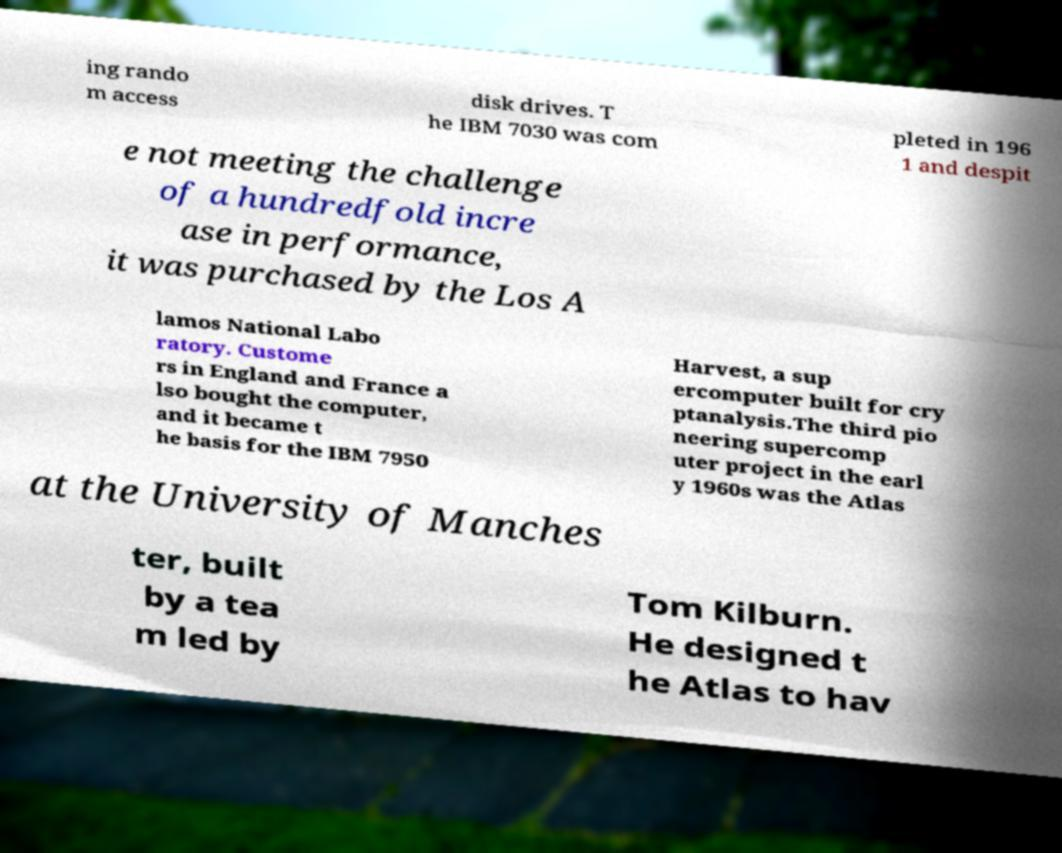For documentation purposes, I need the text within this image transcribed. Could you provide that? ing rando m access disk drives. T he IBM 7030 was com pleted in 196 1 and despit e not meeting the challenge of a hundredfold incre ase in performance, it was purchased by the Los A lamos National Labo ratory. Custome rs in England and France a lso bought the computer, and it became t he basis for the IBM 7950 Harvest, a sup ercomputer built for cry ptanalysis.The third pio neering supercomp uter project in the earl y 1960s was the Atlas at the University of Manches ter, built by a tea m led by Tom Kilburn. He designed t he Atlas to hav 